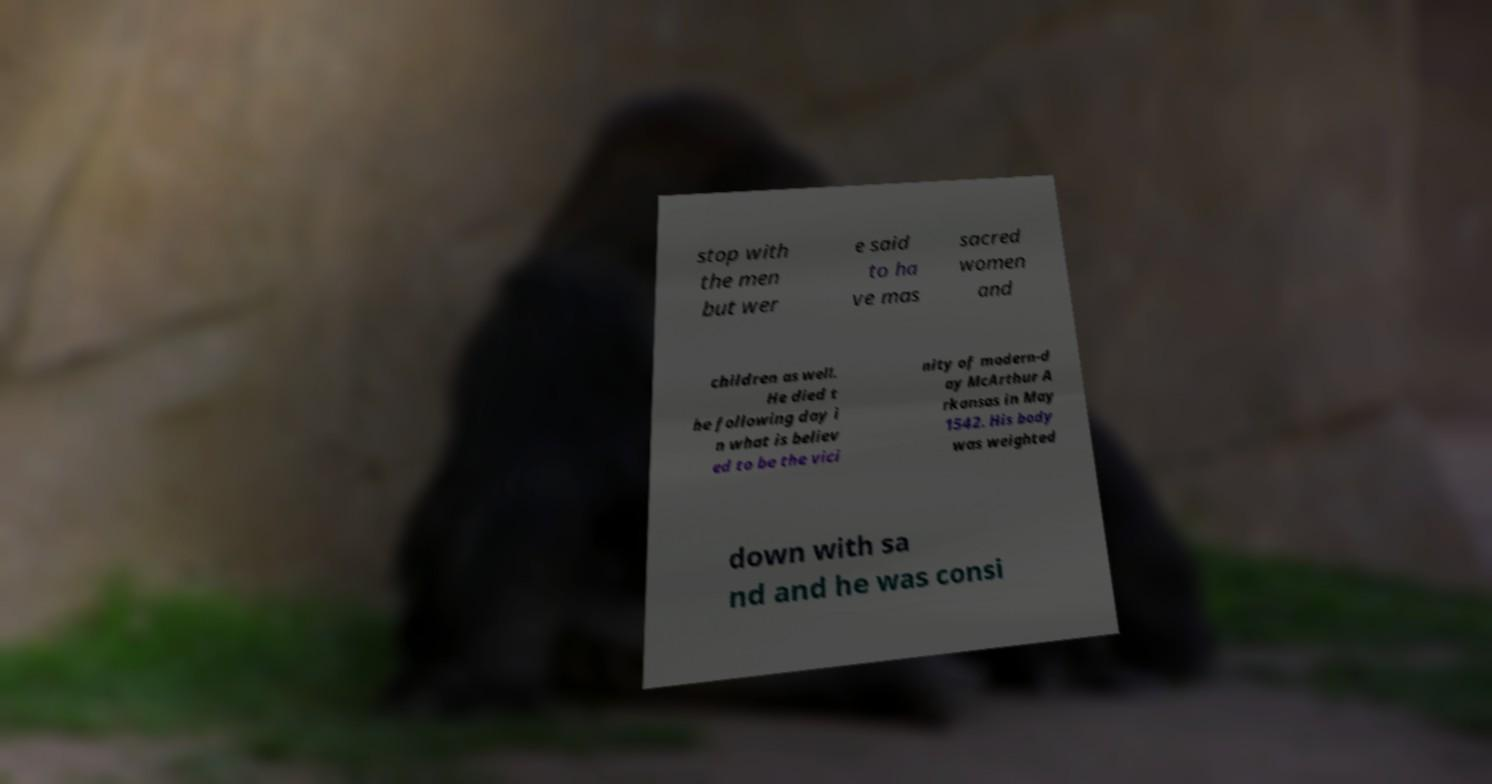Could you assist in decoding the text presented in this image and type it out clearly? stop with the men but wer e said to ha ve mas sacred women and children as well. He died t he following day i n what is believ ed to be the vici nity of modern-d ay McArthur A rkansas in May 1542. His body was weighted down with sa nd and he was consi 